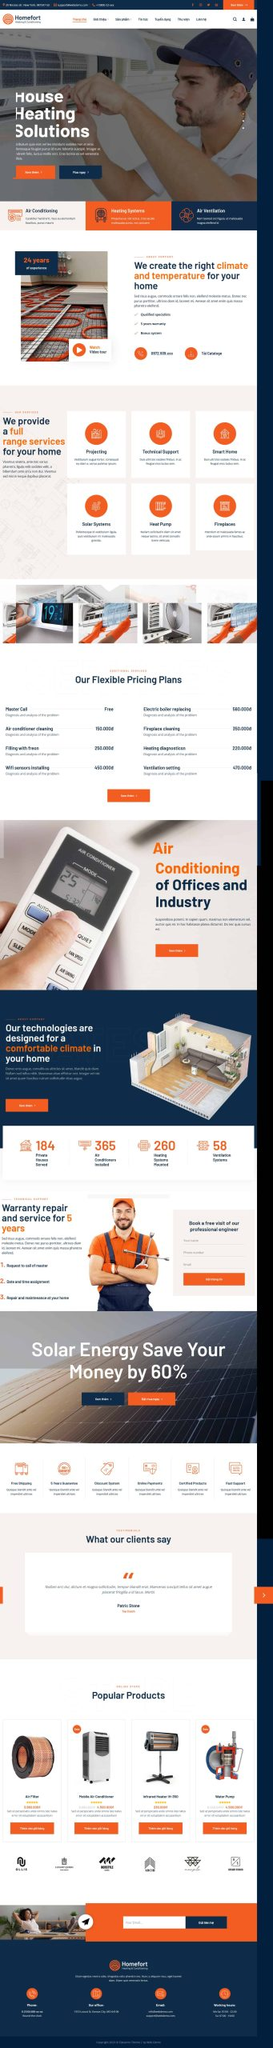Liệt kê 5 ngành nghề, lĩnh vực phù hợp với website này, phân cách các màu sắc bằng dấu phẩy. Chỉ trả về kết quả, phân cách bằng dấy phẩy
 Công nghệ điều hòa không khí, Hệ thống sưởi, Hệ thống thông gió, Hệ thống năng lượng mặt trời, Bơm nhiệt 